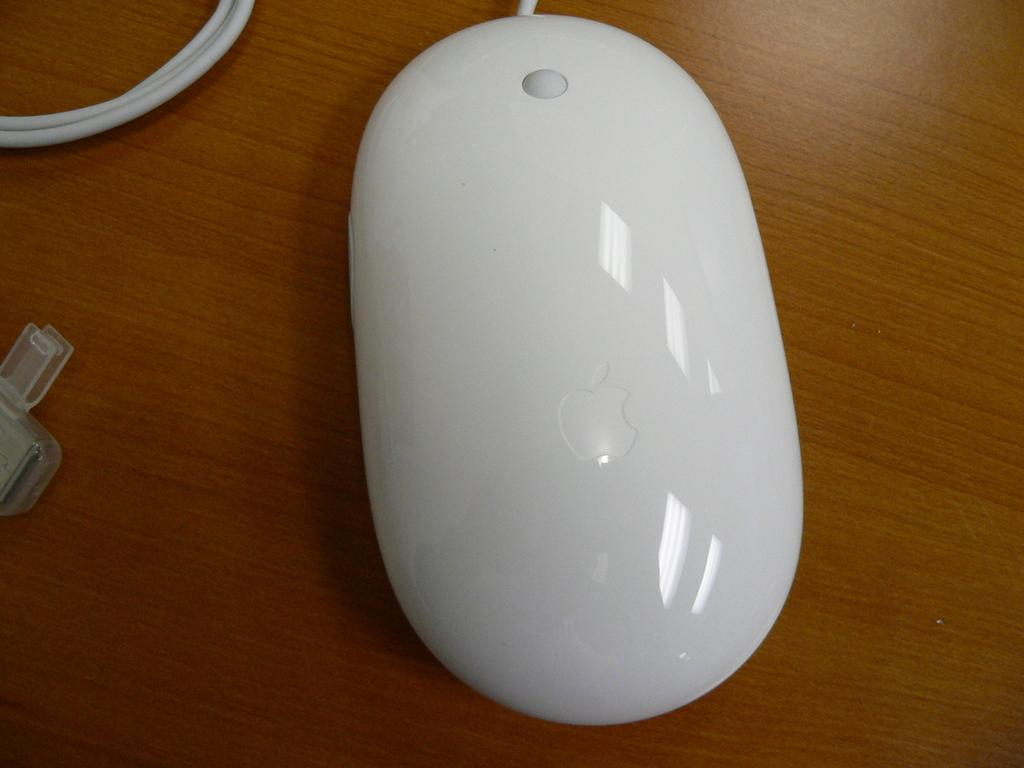What type of animal is in the image? There is a white mouse in the image. Where is the mouse located? The mouse is on a table. What can be seen on the left side of the image? There is a plastic object on the left side of the image. What is visible in the top left corner of the image? There is a cable visible in the top left corner of the image. What type of fold can be seen in the image? There is no fold present in the image. What riddle is the mouse trying to solve in the image? There is no riddle depicted in the image; it simply shows a white mouse on a table. 